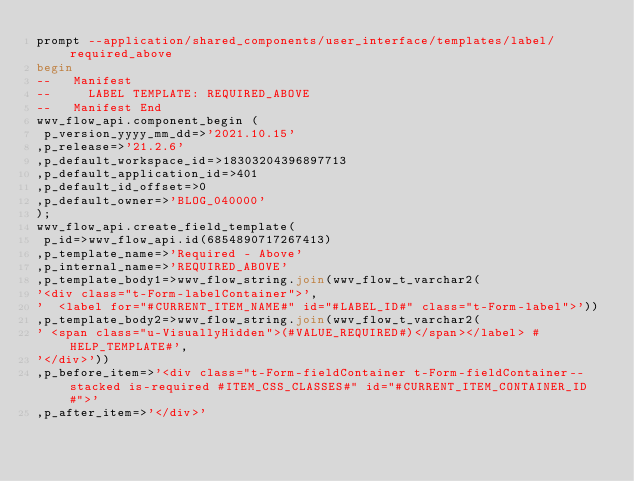<code> <loc_0><loc_0><loc_500><loc_500><_SQL_>prompt --application/shared_components/user_interface/templates/label/required_above
begin
--   Manifest
--     LABEL TEMPLATE: REQUIRED_ABOVE
--   Manifest End
wwv_flow_api.component_begin (
 p_version_yyyy_mm_dd=>'2021.10.15'
,p_release=>'21.2.6'
,p_default_workspace_id=>18303204396897713
,p_default_application_id=>401
,p_default_id_offset=>0
,p_default_owner=>'BLOG_040000'
);
wwv_flow_api.create_field_template(
 p_id=>wwv_flow_api.id(6854890717267413)
,p_template_name=>'Required - Above'
,p_internal_name=>'REQUIRED_ABOVE'
,p_template_body1=>wwv_flow_string.join(wwv_flow_t_varchar2(
'<div class="t-Form-labelContainer">',
'  <label for="#CURRENT_ITEM_NAME#" id="#LABEL_ID#" class="t-Form-label">'))
,p_template_body2=>wwv_flow_string.join(wwv_flow_t_varchar2(
' <span class="u-VisuallyHidden">(#VALUE_REQUIRED#)</span></label> #HELP_TEMPLATE#',
'</div>'))
,p_before_item=>'<div class="t-Form-fieldContainer t-Form-fieldContainer--stacked is-required #ITEM_CSS_CLASSES#" id="#CURRENT_ITEM_CONTAINER_ID#">'
,p_after_item=>'</div>'</code> 